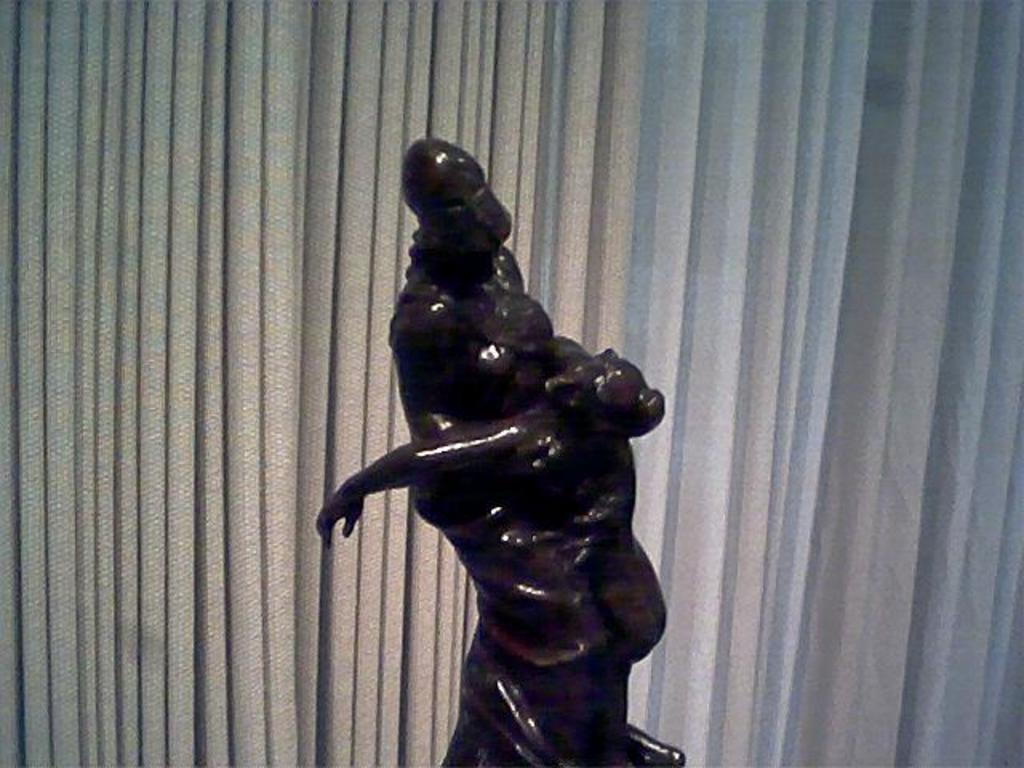What is the main subject of the image? There is a statue in the image. Can you describe the statue's appearance? The statue is brown in color. What other objects can be seen in the image? There are blinds on a window in the image. Where is the kitten playing with a star in the image? There is no kitten or star present in the image; it only features a brown statue and blinds on a window. 